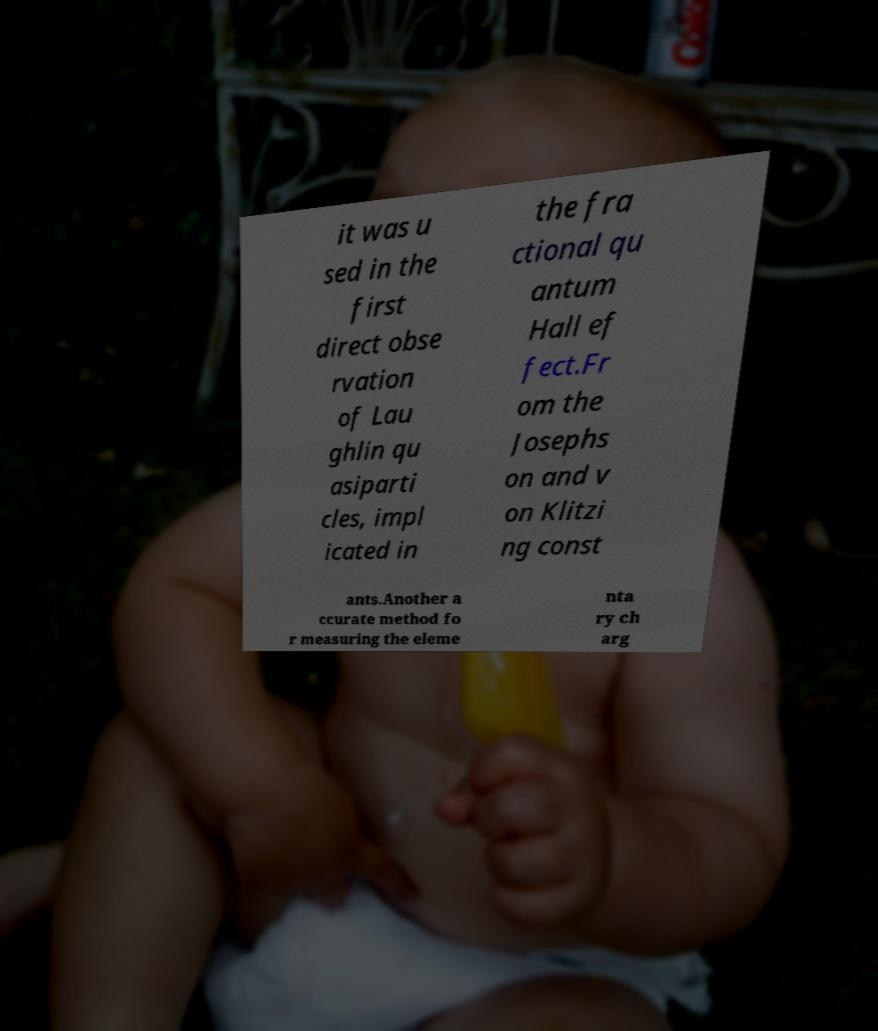Could you extract and type out the text from this image? it was u sed in the first direct obse rvation of Lau ghlin qu asiparti cles, impl icated in the fra ctional qu antum Hall ef fect.Fr om the Josephs on and v on Klitzi ng const ants.Another a ccurate method fo r measuring the eleme nta ry ch arg 